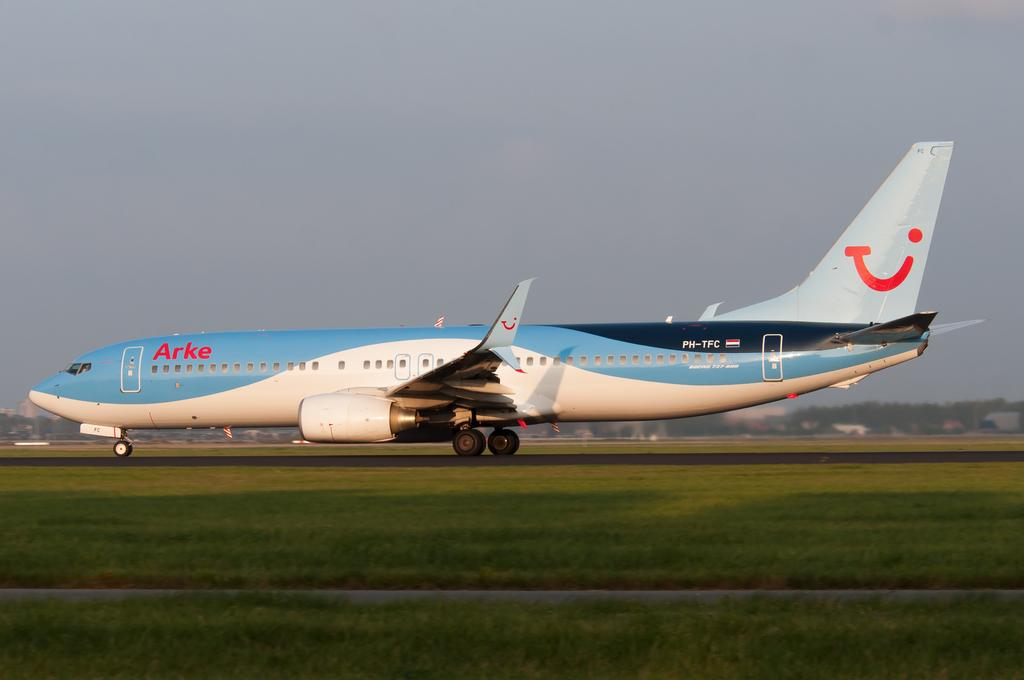<image>
Provide a brief description of the given image. A plane has the word Arke in red near its front door. 